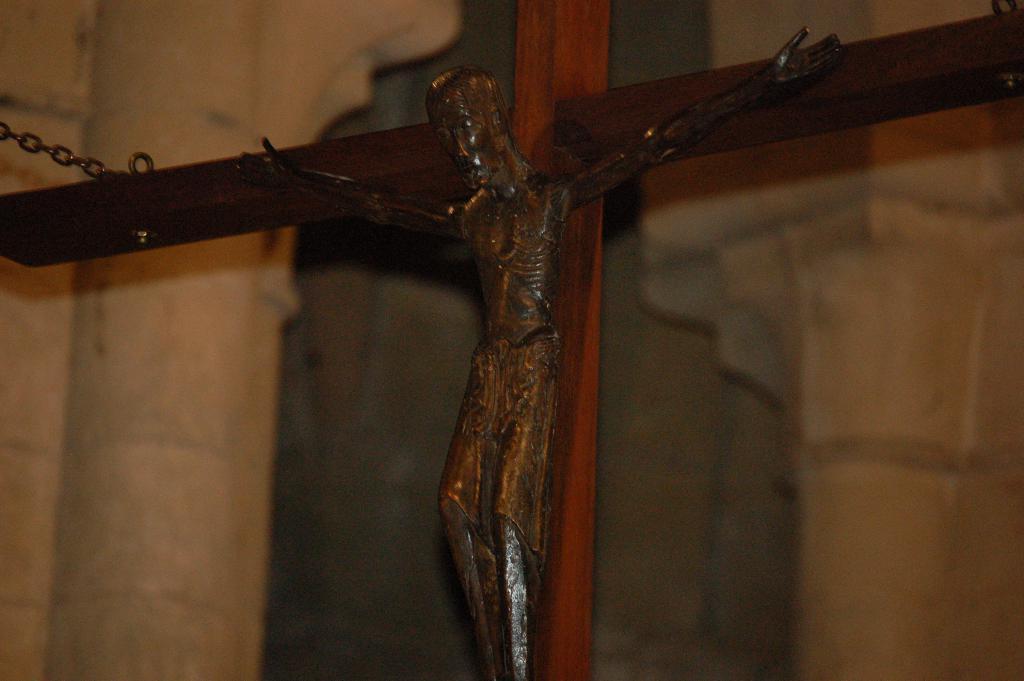Could you give a brief overview of what you see in this image? This picture contains Crucifix of the image of the Jesus is placed on the cross. Behind that, we see a white wall. This picture might be clicked in the church. 